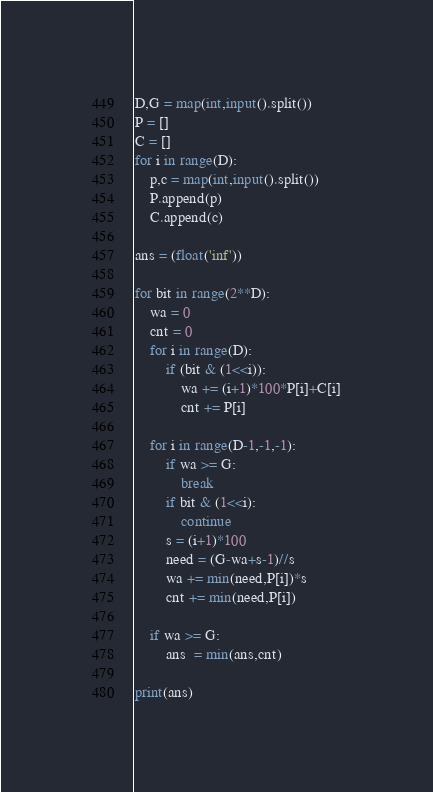<code> <loc_0><loc_0><loc_500><loc_500><_Python_>D,G = map(int,input().split())
P = []
C = []
for i in range(D):
	p,c = map(int,input().split())
	P.append(p)
	C.append(c)

ans = (float('inf'))

for bit in range(2**D):
	wa = 0
	cnt = 0
	for i in range(D):
		if (bit & (1<<i)):
			wa += (i+1)*100*P[i]+C[i]
			cnt += P[i]
		
	for i in range(D-1,-1,-1):
		if wa >= G:
			break
		if bit & (1<<i):
			continue
		s = (i+1)*100
		need = (G-wa+s-1)//s
		wa += min(need,P[i])*s
		cnt += min(need,P[i])

	if wa >= G:
		ans  = min(ans,cnt)

print(ans)</code> 